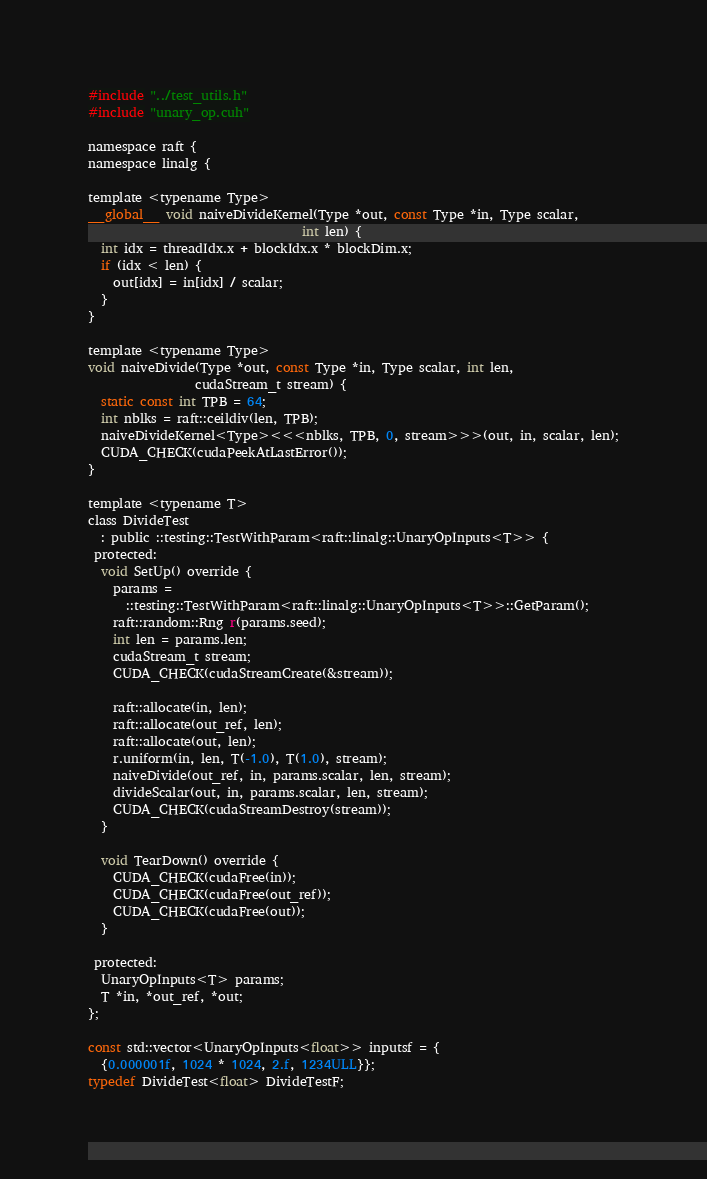<code> <loc_0><loc_0><loc_500><loc_500><_Cuda_>#include "../test_utils.h"
#include "unary_op.cuh"

namespace raft {
namespace linalg {

template <typename Type>
__global__ void naiveDivideKernel(Type *out, const Type *in, Type scalar,
                                  int len) {
  int idx = threadIdx.x + blockIdx.x * blockDim.x;
  if (idx < len) {
    out[idx] = in[idx] / scalar;
  }
}

template <typename Type>
void naiveDivide(Type *out, const Type *in, Type scalar, int len,
                 cudaStream_t stream) {
  static const int TPB = 64;
  int nblks = raft::ceildiv(len, TPB);
  naiveDivideKernel<Type><<<nblks, TPB, 0, stream>>>(out, in, scalar, len);
  CUDA_CHECK(cudaPeekAtLastError());
}

template <typename T>
class DivideTest
  : public ::testing::TestWithParam<raft::linalg::UnaryOpInputs<T>> {
 protected:
  void SetUp() override {
    params =
      ::testing::TestWithParam<raft::linalg::UnaryOpInputs<T>>::GetParam();
    raft::random::Rng r(params.seed);
    int len = params.len;
    cudaStream_t stream;
    CUDA_CHECK(cudaStreamCreate(&stream));

    raft::allocate(in, len);
    raft::allocate(out_ref, len);
    raft::allocate(out, len);
    r.uniform(in, len, T(-1.0), T(1.0), stream);
    naiveDivide(out_ref, in, params.scalar, len, stream);
    divideScalar(out, in, params.scalar, len, stream);
    CUDA_CHECK(cudaStreamDestroy(stream));
  }

  void TearDown() override {
    CUDA_CHECK(cudaFree(in));
    CUDA_CHECK(cudaFree(out_ref));
    CUDA_CHECK(cudaFree(out));
  }

 protected:
  UnaryOpInputs<T> params;
  T *in, *out_ref, *out;
};

const std::vector<UnaryOpInputs<float>> inputsf = {
  {0.000001f, 1024 * 1024, 2.f, 1234ULL}};
typedef DivideTest<float> DivideTestF;</code> 